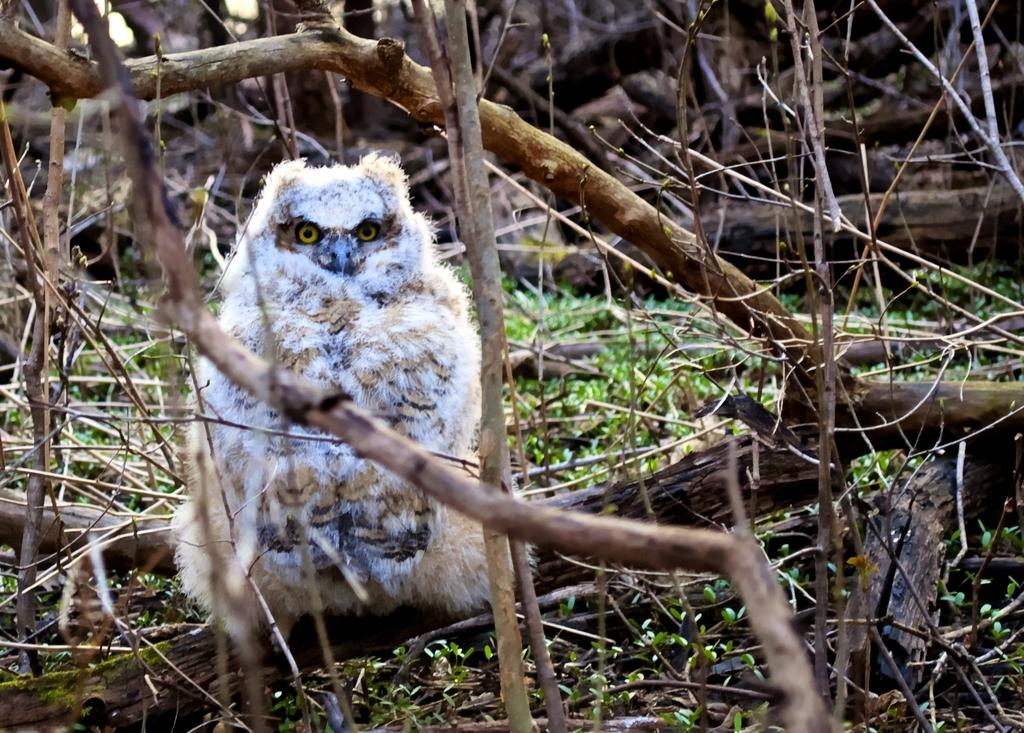What type of animal can be seen in the image? There is a bird in the image. What is the bird perched on or near? The bird is near dry tree branches in the image. What type of vegetation is present in the image? There is grass in the image. What type of screw can be seen holding the bird's wings together in the image? There is no screw present in the image, and the bird's wings are not held together. 